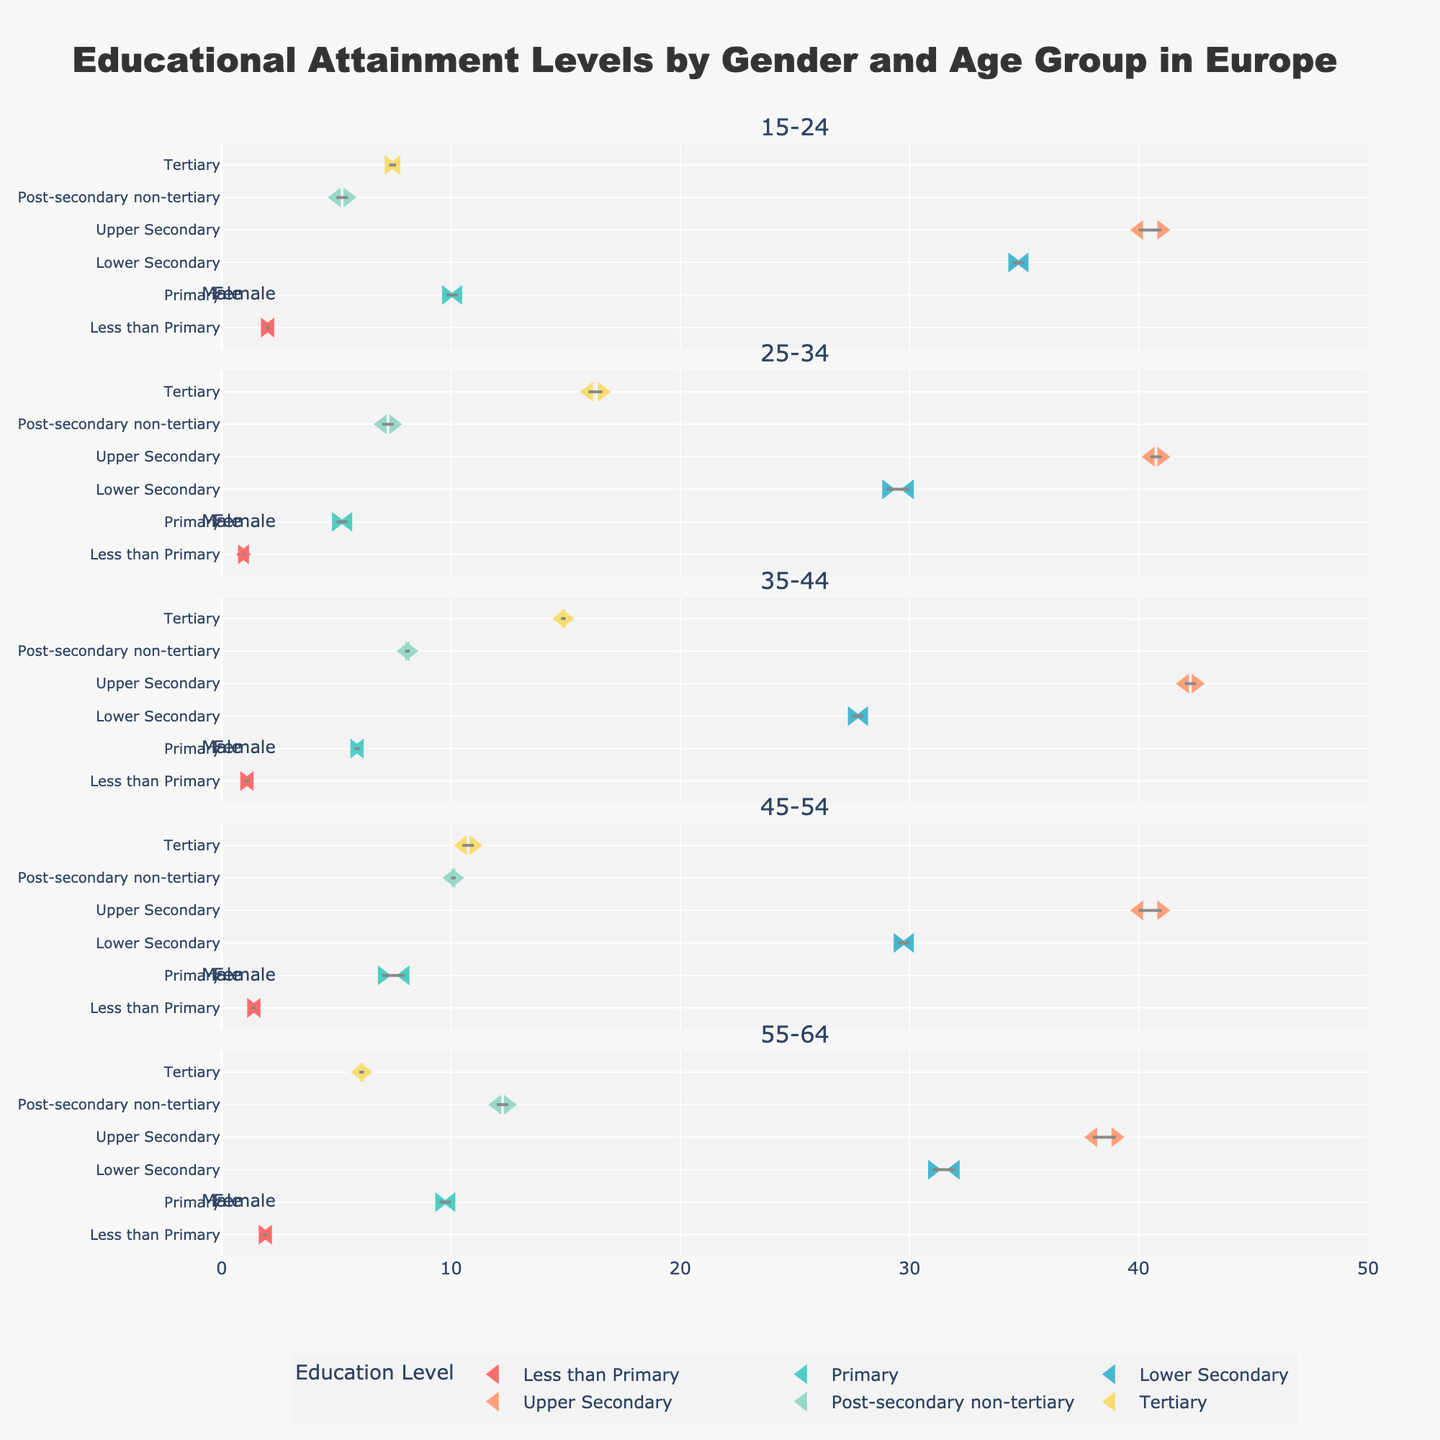what is the title of the figure? The title is displayed prominently at the top of the figure. It reads: "Educational Attainment Levels by Gender and Age Group in Europe"
Answer: Educational Attainment Levels by Gender and Age Group in Europe How many different age groups are presented in the figure? The figure contains a subtitle for each age group, and there are five such subtitles. They are: "15-24", "25-34", "35-44", "45-54", and "55-64"
Answer: 5 What is the highest educational attainment level for females aged 25-34? For females aged 25-34, the topmost marker on the y-axis corresponds to the "Tertiary" level, represented on the x-axis by a value of 16.6
Answer: Tertiary Which gender has a higher percentage of individuals with less than primary education in the 35-44 age group? Checking the corresponding markers for males and females in the "35-44" age group, males have 1.2% while females have 1.0% in the "Less than Primary" category
Answer: Male What is the percentage difference in upper secondary education attainment between males and females aged 15-24? The upper secondary values for males and females aged 15-24 are 40% and 41% respectively. The difference is calculated as
Answer: 1% Which education level shows the least gender discrepancy among individuals aged 55-64? For the 55-64 age group, each education level's markers show the same discrepancies for both males and females. The smallest difference is in "Less than Primary," where males have 2% and females, 1.8%, resulting in a 0.2% difference
Answer: Less than Primary Which age group has the closest tertiary education attainment percentages between genders? Comparing the tertiary education markers for each age group, the 35-44 age group shows the least difference with males at 14.8% and females at 15.0%, a difference of only 0.2%
Answer: 35-44 What is the overall trend in the tertiary education level as age increases for both males and females? Observing the tertiary education markers across all age groups, there is a general downward trend as age increases, indicating lower tertiary education percentages among older age groups for both genders
Answer: Downward trend What's the combined average percentage of males and females with primary education in the 45-54 age group? The primary education percentages for males and females aged 45-54 is 8% and 7% respectively. Therefore, the combined average is (8+7)/2 = 7.5
Answer: 7.5 In which educational attainment level is the gender gap largest for the 25-34 age group? In the 25-34 age group, examining the discrepancies among the education levels, the largest difference is in "Primary" with males at 5.5% and females at 5%, resulting in an absolute difference of 0.5%
Answer: Primary 